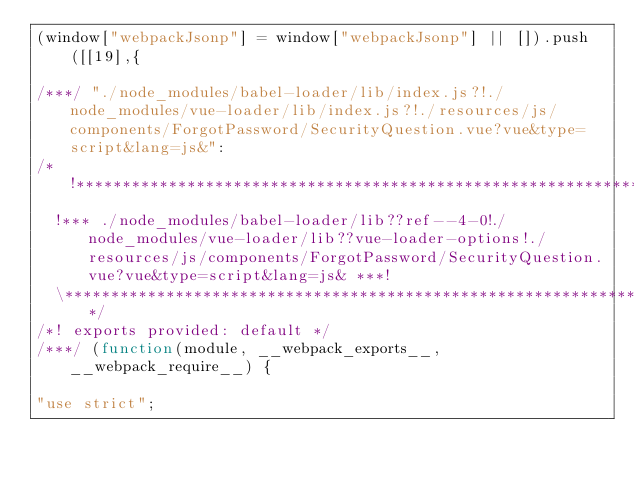Convert code to text. <code><loc_0><loc_0><loc_500><loc_500><_JavaScript_>(window["webpackJsonp"] = window["webpackJsonp"] || []).push([[19],{

/***/ "./node_modules/babel-loader/lib/index.js?!./node_modules/vue-loader/lib/index.js?!./resources/js/components/ForgotPassword/SecurityQuestion.vue?vue&type=script&lang=js&":
/*!******************************************************************************************************************************************************************************************!*\
  !*** ./node_modules/babel-loader/lib??ref--4-0!./node_modules/vue-loader/lib??vue-loader-options!./resources/js/components/ForgotPassword/SecurityQuestion.vue?vue&type=script&lang=js& ***!
  \******************************************************************************************************************************************************************************************/
/*! exports provided: default */
/***/ (function(module, __webpack_exports__, __webpack_require__) {

"use strict";</code> 